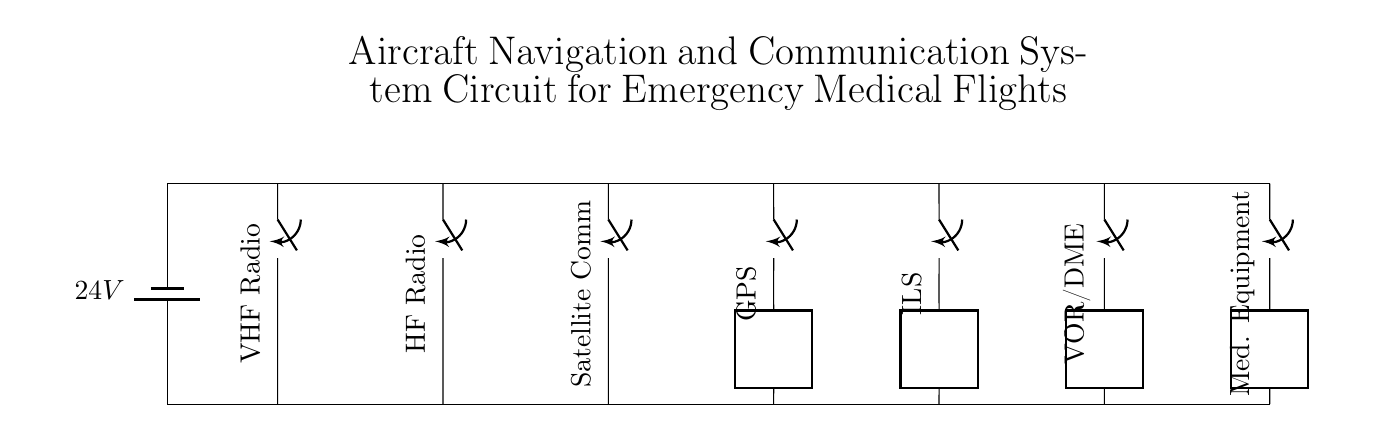What is the voltage of the main power supply? The circuit indicates that the main power supply is a battery rated at 24V, which is shown directly in the diagram.
Answer: 24V What type of communication systems are present in this circuit? The diagram includes VHF Radio, HF Radio, and Satellite Comm, which are specified by their labels near the corresponding components in the circuit.
Answer: VHF Radio, HF Radio, Satellite Comm How many navigation systems are shown in the circuit? The navigation systems include GPS, ILS, and VOR/DME, as indicated by the labels in the diagram, making a total of three navigation systems.
Answer: 3 What is the purpose of the switch components? Each switch in the circuit allows for the operation or cutoff of the respective communication or navigation system, controlling their functionality based on necessity.
Answer: Control operation Which component is specifically designated for medical equipment? The circuit diagram has a component labeled "Med. Equipment," which directly indicates its purpose for medical equipment necessary for emergency medical flights.
Answer: Med. Equipment What systems will receive power when the main switch is closed? When the main switch is closed, all the systems indicated in the circuit—communication and navigation systems as well as medical equipment—will receive power, as they are all powered from the main battery supply.
Answer: All systems 